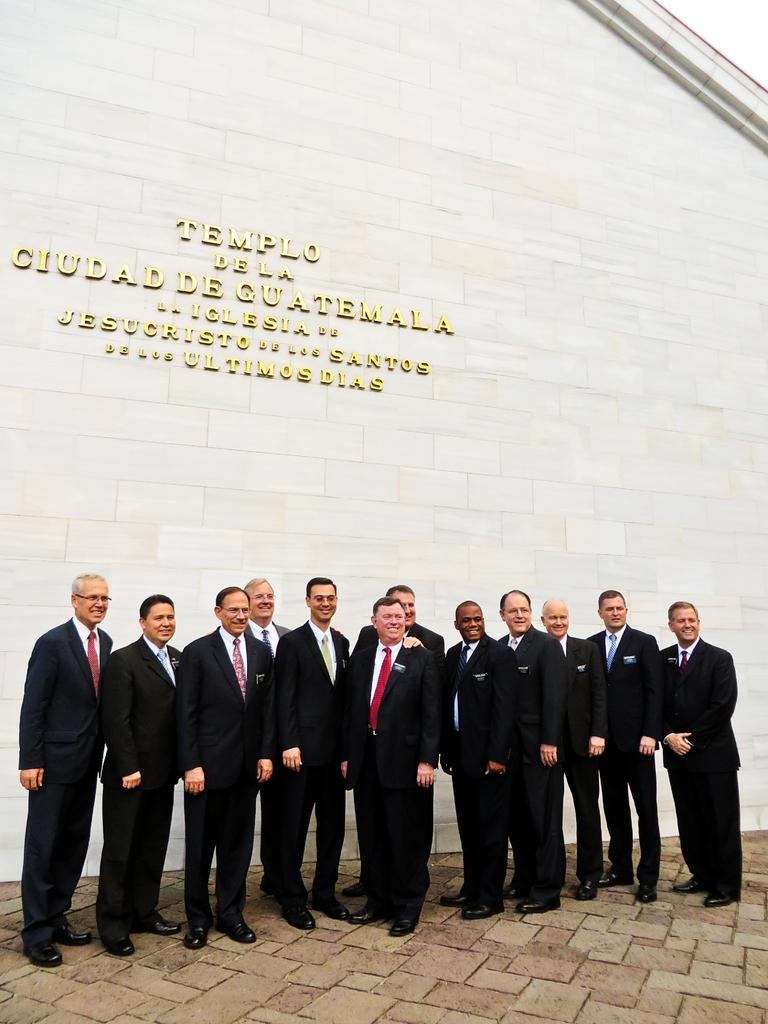What can be seen in the image involving people? There are people standing in the image. What type of structure is present in the image? There is a wall in the image. What is written or displayed on the wall? There is text on the wall. What type of fruit can be seen hanging from the wall in the image? There is no fruit, such as a pear, present in the image. The wall features text, but no fruit is visible. 